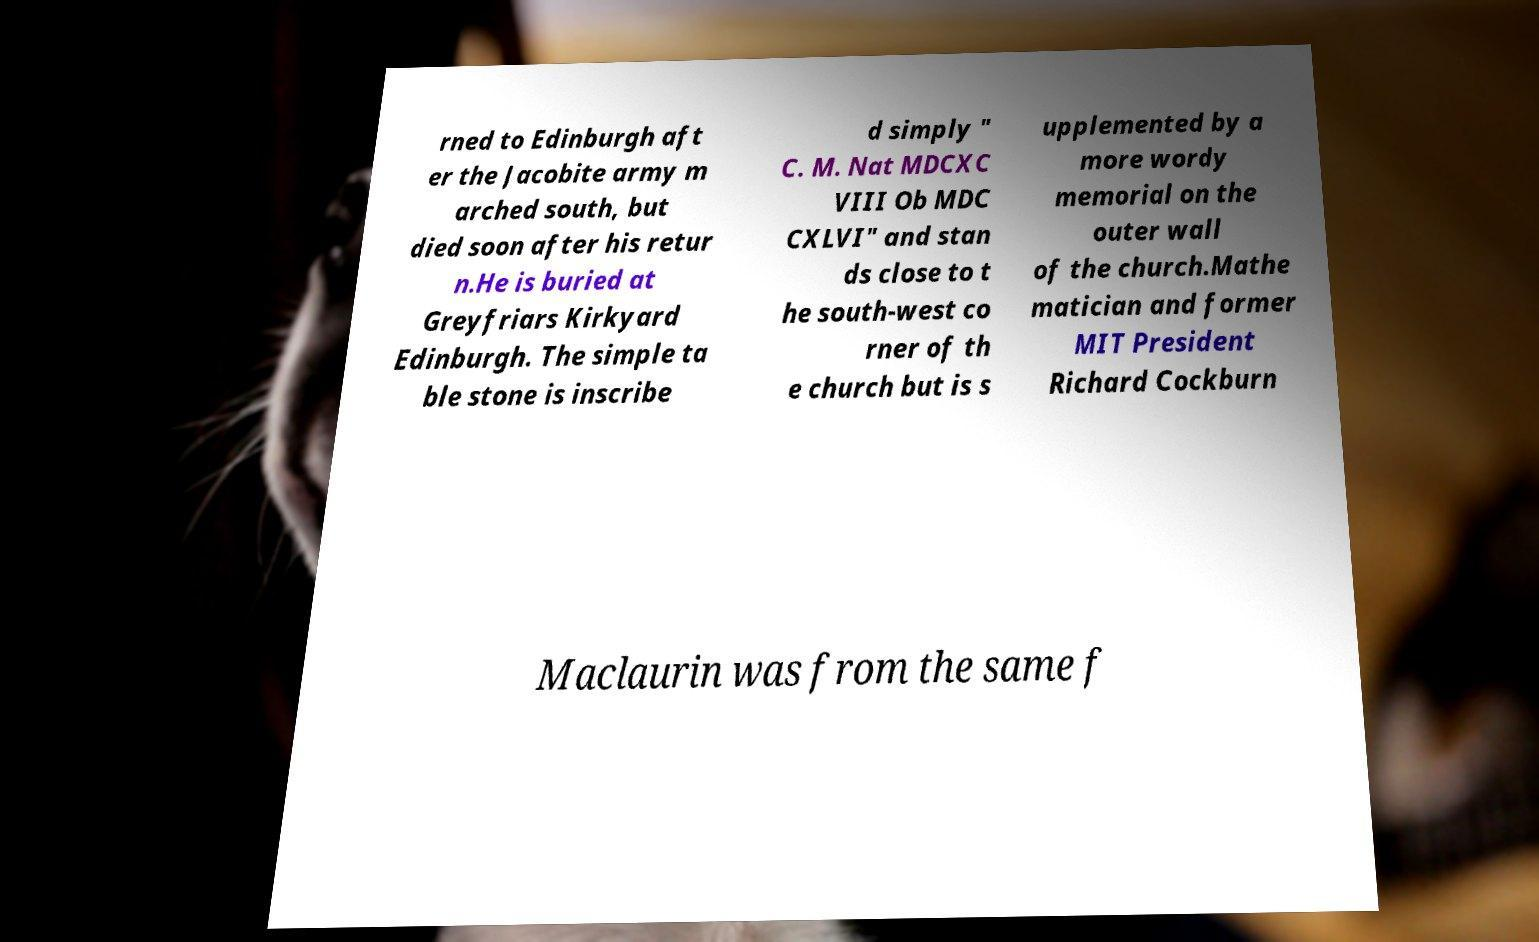Could you assist in decoding the text presented in this image and type it out clearly? rned to Edinburgh aft er the Jacobite army m arched south, but died soon after his retur n.He is buried at Greyfriars Kirkyard Edinburgh. The simple ta ble stone is inscribe d simply " C. M. Nat MDCXC VIII Ob MDC CXLVI" and stan ds close to t he south-west co rner of th e church but is s upplemented by a more wordy memorial on the outer wall of the church.Mathe matician and former MIT President Richard Cockburn Maclaurin was from the same f 